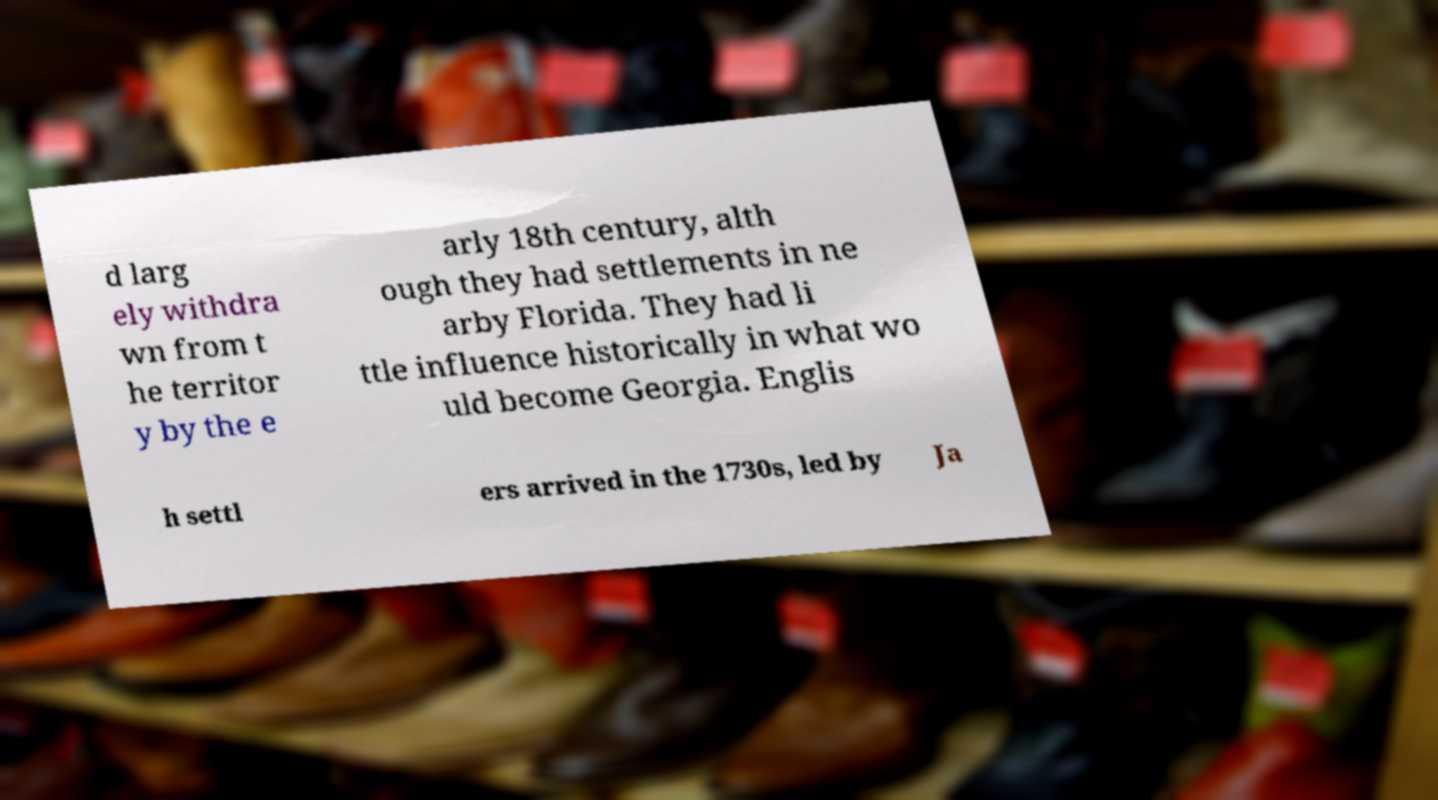Please identify and transcribe the text found in this image. d larg ely withdra wn from t he territor y by the e arly 18th century, alth ough they had settlements in ne arby Florida. They had li ttle influence historically in what wo uld become Georgia. Englis h settl ers arrived in the 1730s, led by Ja 